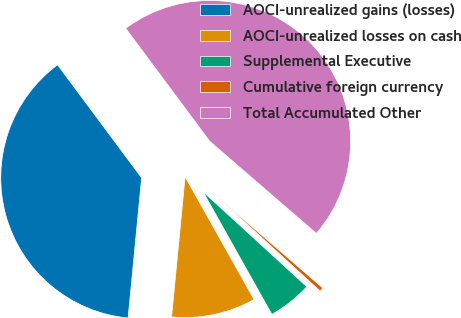Convert chart. <chart><loc_0><loc_0><loc_500><loc_500><pie_chart><fcel>AOCI-unrealized gains (losses)<fcel>AOCI-unrealized losses on cash<fcel>Supplemental Executive<fcel>Cumulative foreign currency<fcel>Total Accumulated Other<nl><fcel>38.29%<fcel>9.67%<fcel>5.06%<fcel>0.46%<fcel>46.52%<nl></chart> 